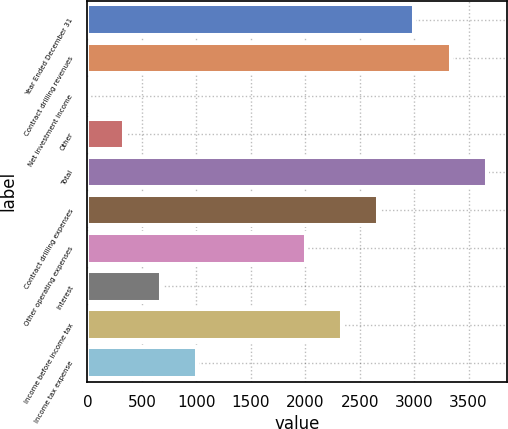<chart> <loc_0><loc_0><loc_500><loc_500><bar_chart><fcel>Year Ended December 31<fcel>Contract drilling revenues<fcel>Net investment income<fcel>Other<fcel>Total<fcel>Contract drilling expenses<fcel>Other operating expenses<fcel>Interest<fcel>Income before income tax<fcel>Income tax expense<nl><fcel>3002.2<fcel>3335<fcel>7<fcel>339.8<fcel>3667.8<fcel>2669.4<fcel>2003.8<fcel>672.6<fcel>2336.6<fcel>1005.4<nl></chart> 